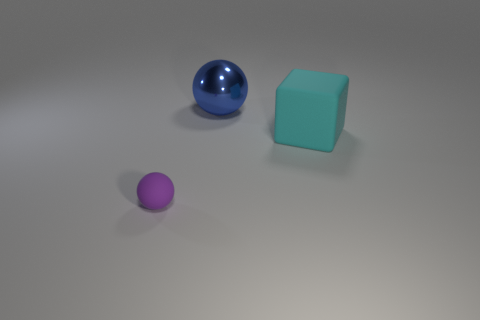Are there an equal number of big cyan blocks behind the large blue metallic object and large blue rubber cylinders? Yes, the image displays one large cyan block and one large blue rubber cylinder positioned symmetrically relative to the central blue metallic object. 